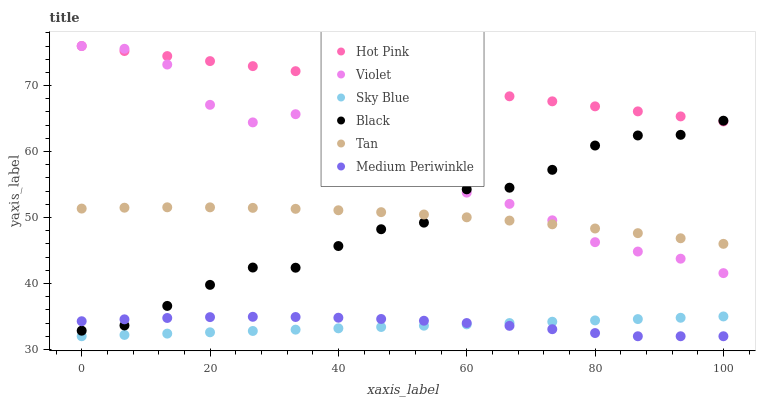Does Sky Blue have the minimum area under the curve?
Answer yes or no. Yes. Does Hot Pink have the maximum area under the curve?
Answer yes or no. Yes. Does Medium Periwinkle have the minimum area under the curve?
Answer yes or no. No. Does Medium Periwinkle have the maximum area under the curve?
Answer yes or no. No. Is Sky Blue the smoothest?
Answer yes or no. Yes. Is Violet the roughest?
Answer yes or no. Yes. Is Medium Periwinkle the smoothest?
Answer yes or no. No. Is Medium Periwinkle the roughest?
Answer yes or no. No. Does Medium Periwinkle have the lowest value?
Answer yes or no. Yes. Does Black have the lowest value?
Answer yes or no. No. Does Violet have the highest value?
Answer yes or no. Yes. Does Black have the highest value?
Answer yes or no. No. Is Medium Periwinkle less than Violet?
Answer yes or no. Yes. Is Hot Pink greater than Tan?
Answer yes or no. Yes. Does Hot Pink intersect Black?
Answer yes or no. Yes. Is Hot Pink less than Black?
Answer yes or no. No. Is Hot Pink greater than Black?
Answer yes or no. No. Does Medium Periwinkle intersect Violet?
Answer yes or no. No. 